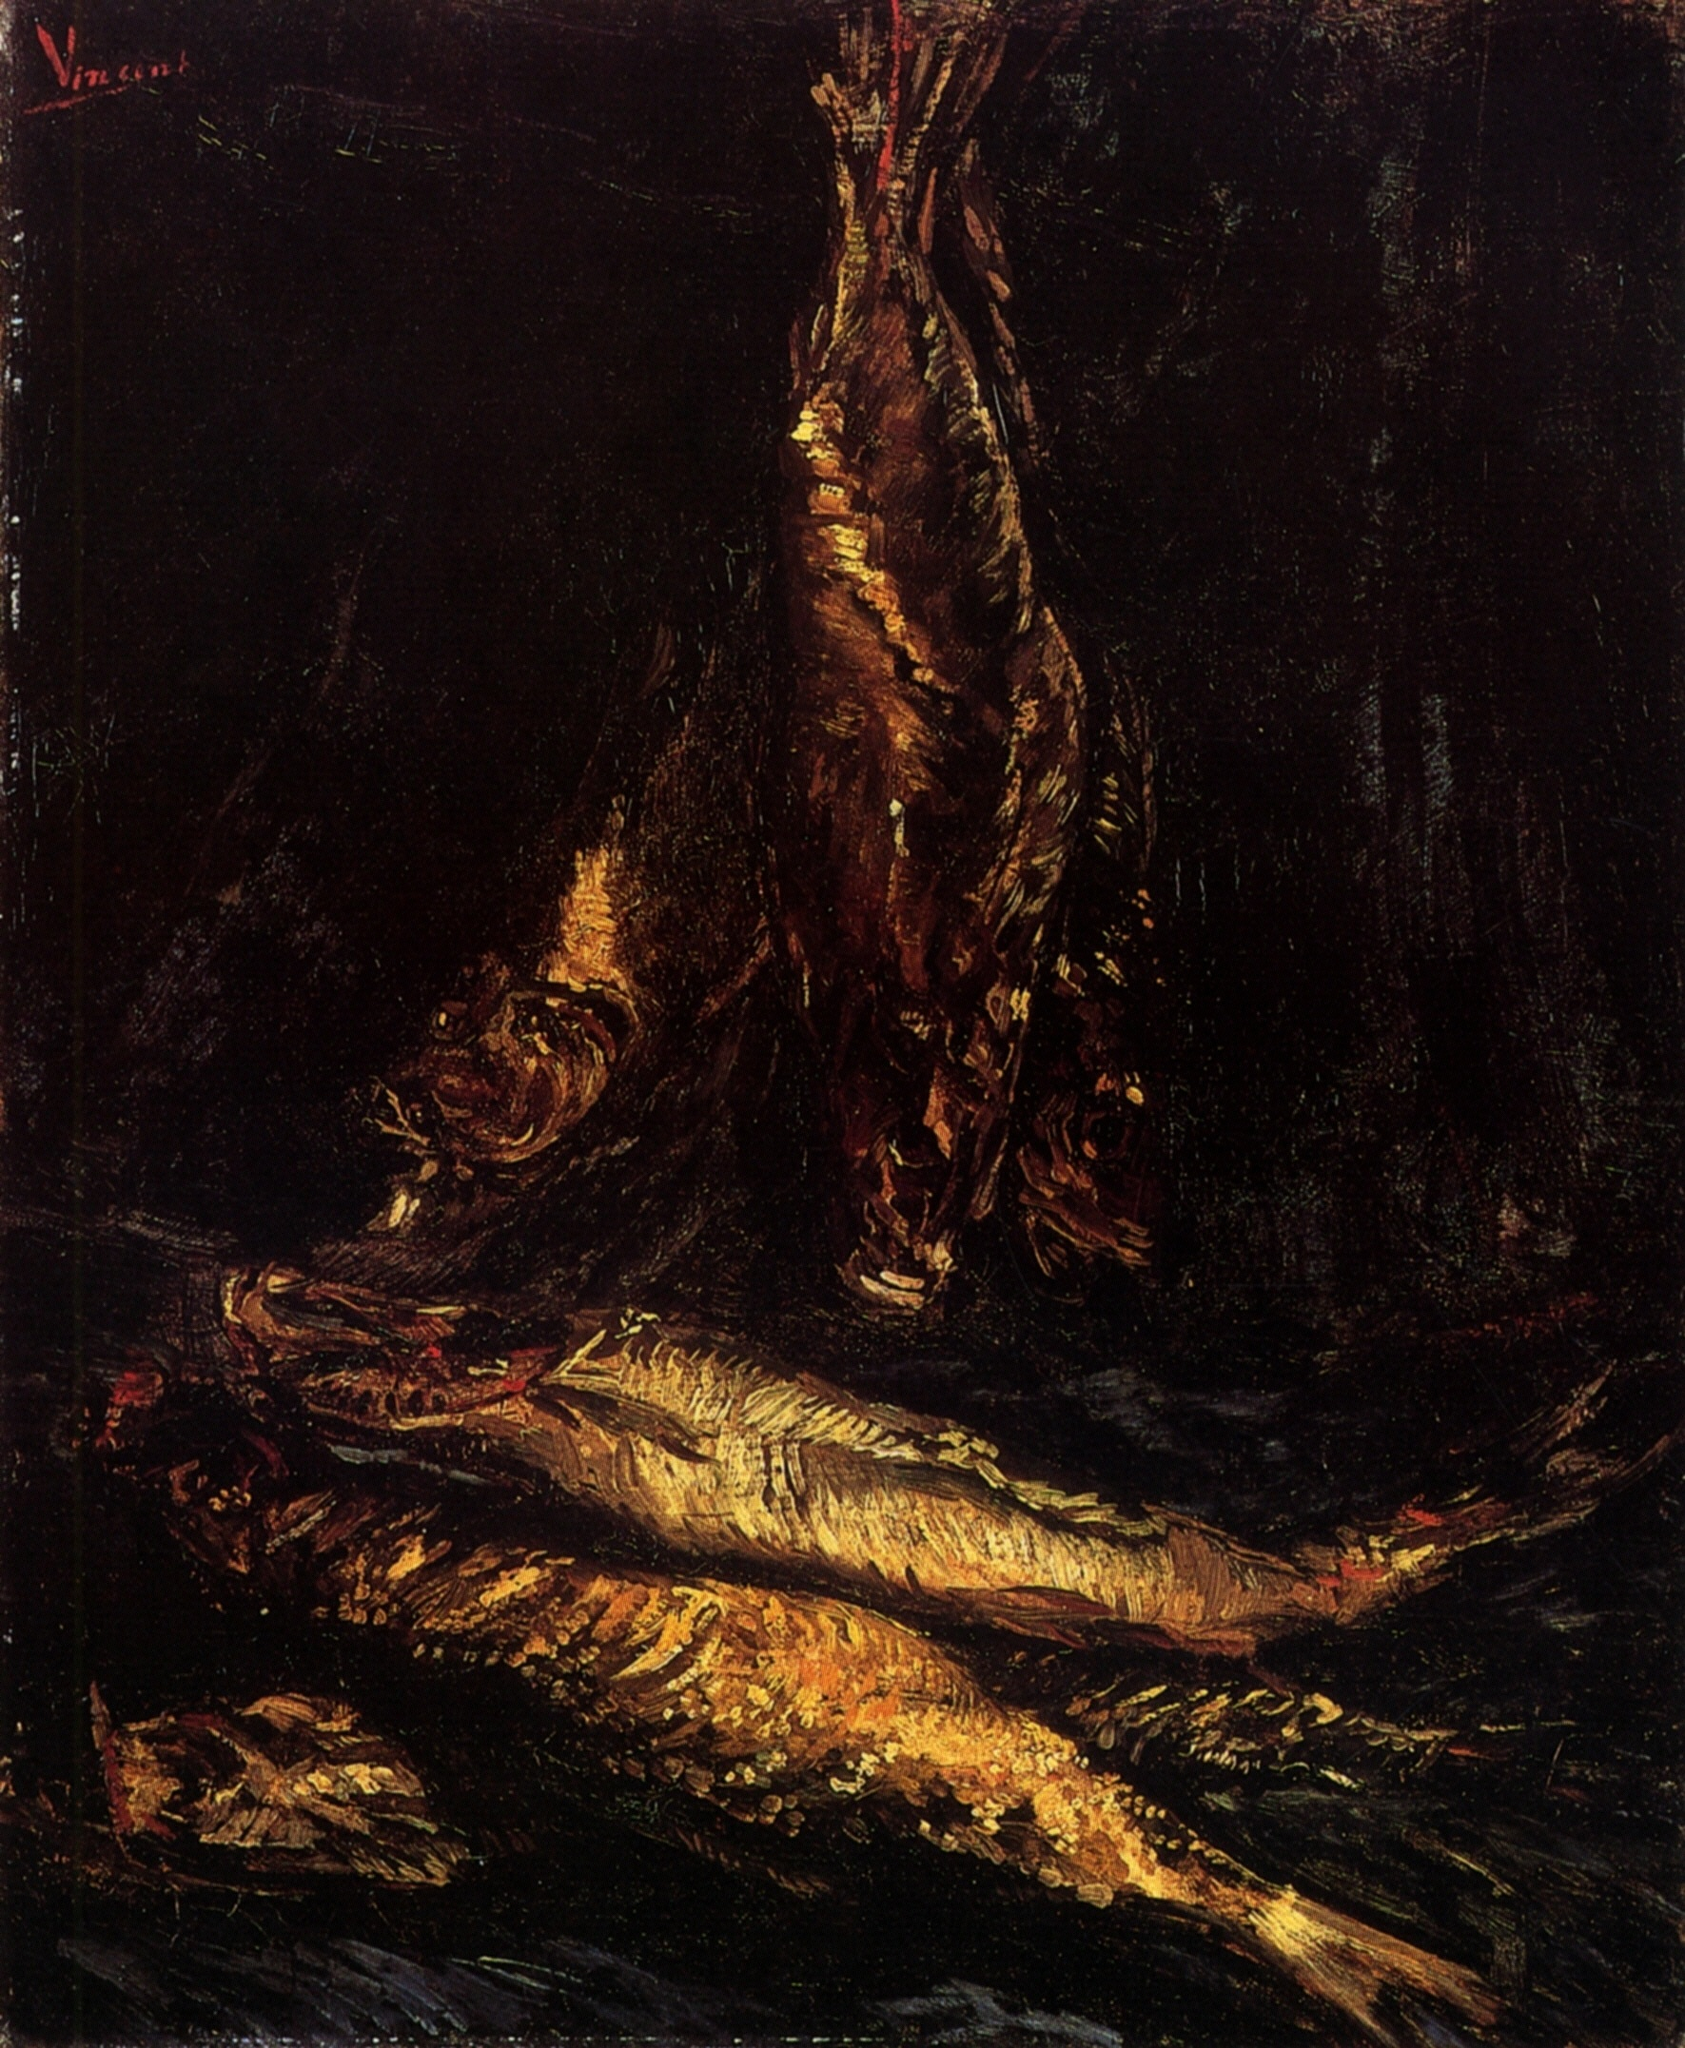Can you tell us more about the artistic techniques visible in this painting? The painting uses thick, heavy brushstrokes that add depth and texture to the depiction of the fish. These strokes are characteristic of post-impressionist methods, where the emphasis is often on symbolic content, structured forms, and vivid colors. This technique helps to convey not just the appearance but also the essence and vitality of the organic subjects, despite their lifelessness in reality. 